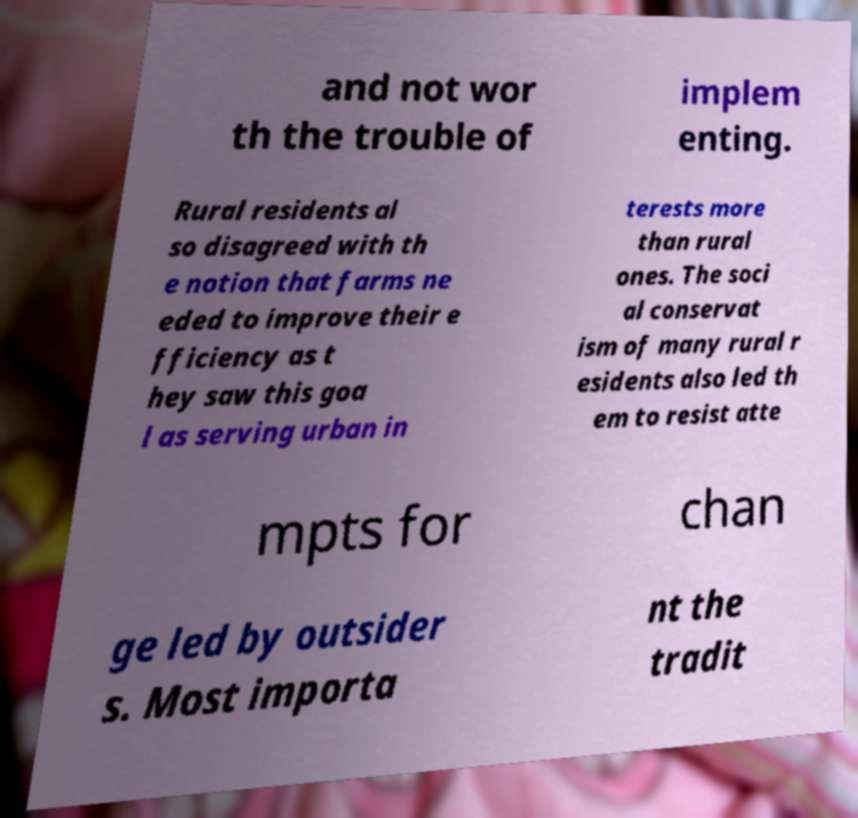There's text embedded in this image that I need extracted. Can you transcribe it verbatim? and not wor th the trouble of implem enting. Rural residents al so disagreed with th e notion that farms ne eded to improve their e fficiency as t hey saw this goa l as serving urban in terests more than rural ones. The soci al conservat ism of many rural r esidents also led th em to resist atte mpts for chan ge led by outsider s. Most importa nt the tradit 